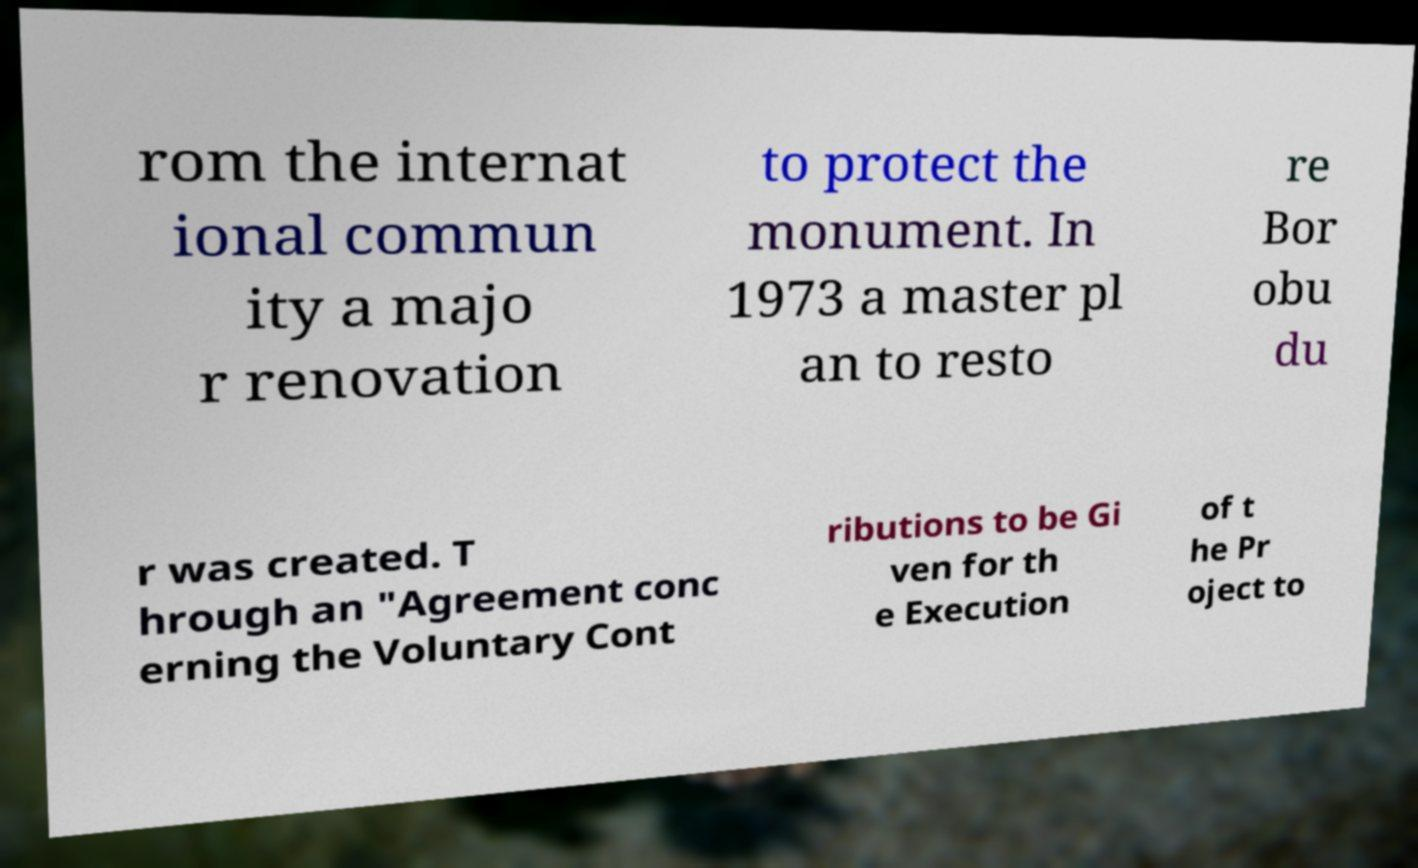I need the written content from this picture converted into text. Can you do that? rom the internat ional commun ity a majo r renovation to protect the monument. In 1973 a master pl an to resto re Bor obu du r was created. T hrough an "Agreement conc erning the Voluntary Cont ributions to be Gi ven for th e Execution of t he Pr oject to 